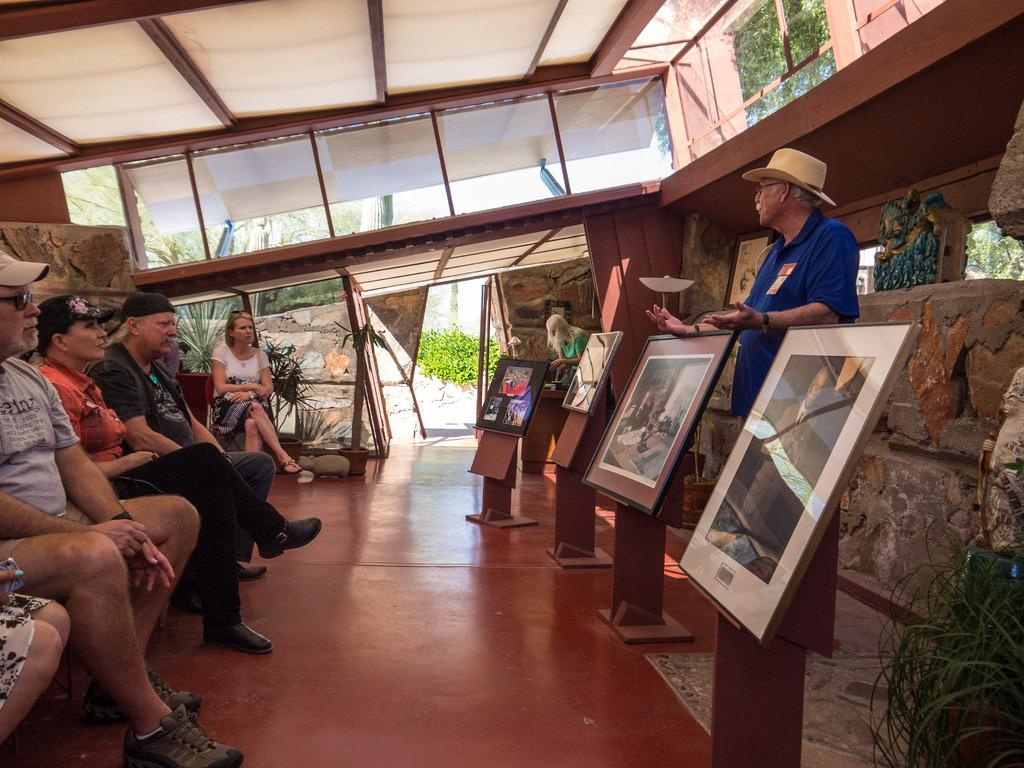What are the people in the image doing? There are persons sitting on chairs in the image. Is there anyone standing in the image? Yes, there is a man standing on the floor. What can be seen hanging on the wall? There are frames in the image. What type of vegetation is present in the image? There are plants in the image. What is the background of the image? There is a wall in the image, and trees are visible through the glass. How many dimes can be seen on the floor in the image? There are no dimes present in the image. What type of pump is visible in the image? There is no pump present in the image. 